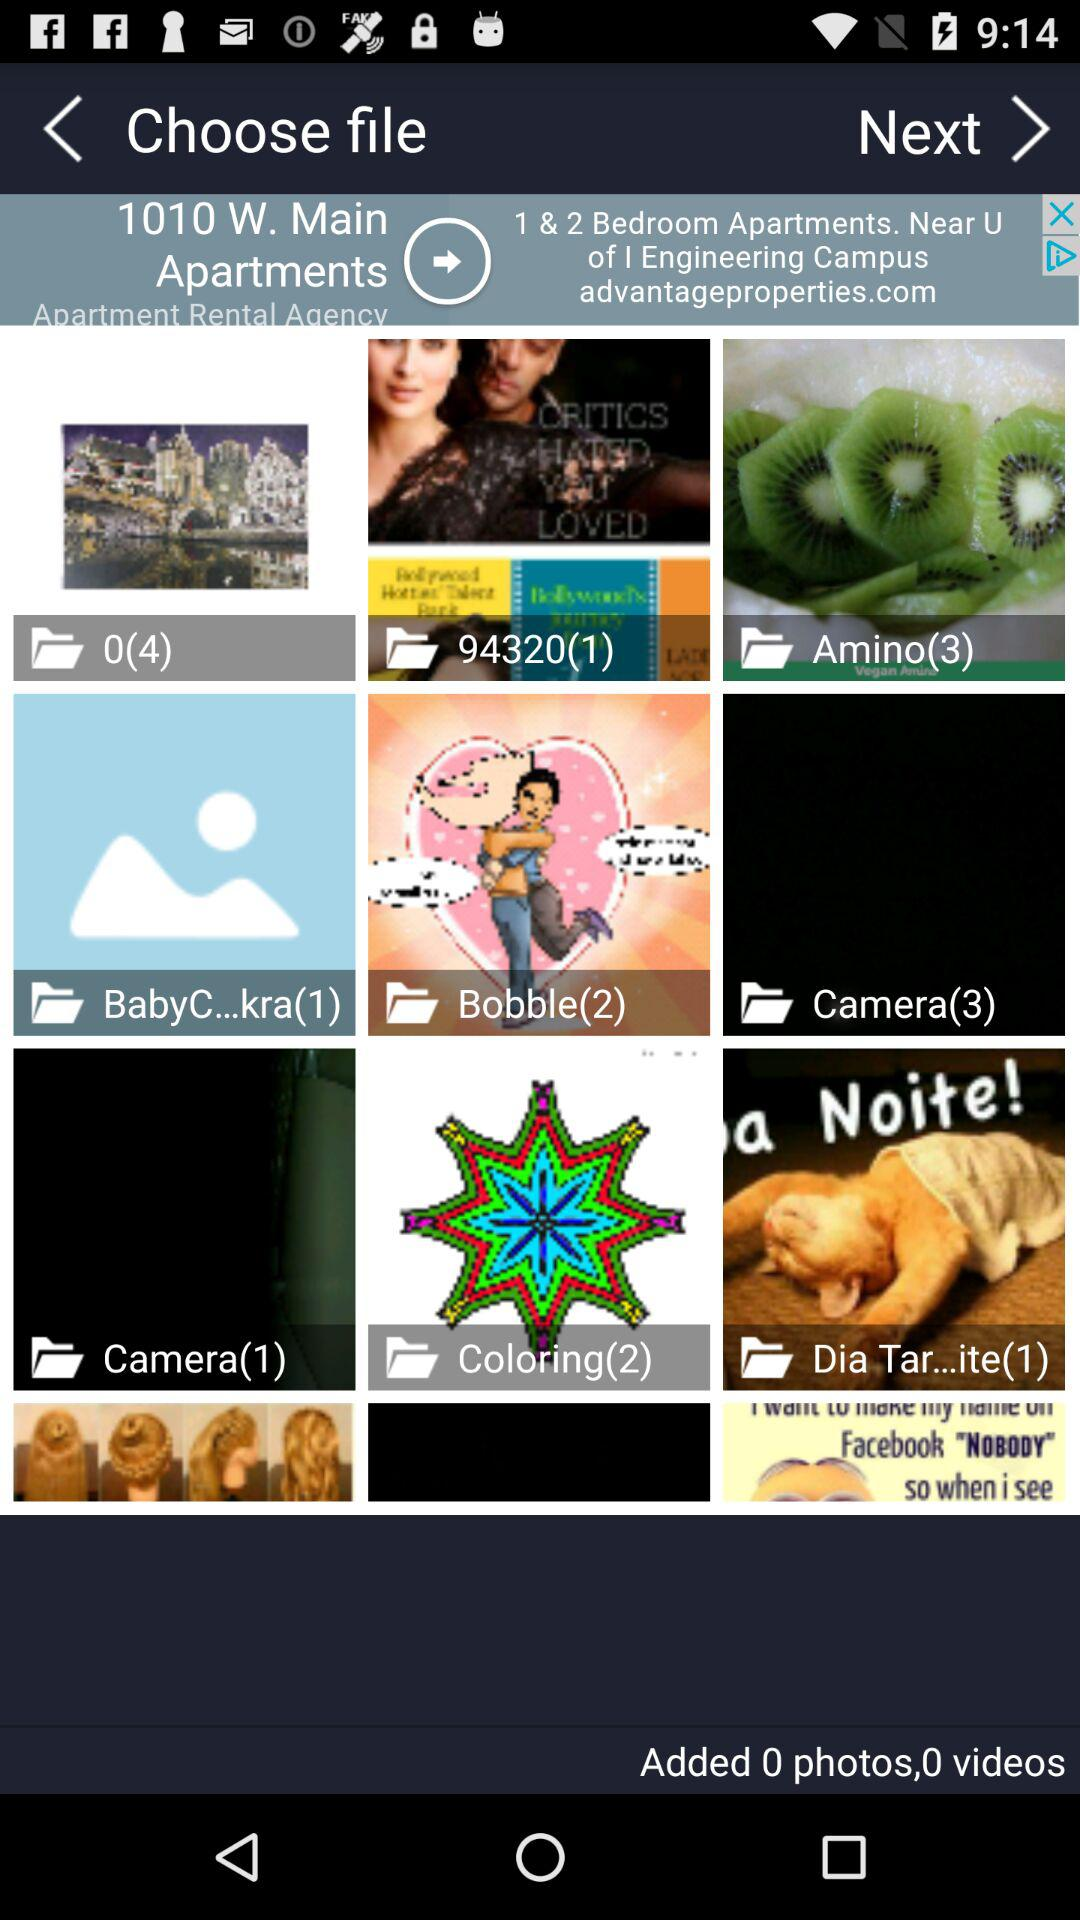What is the number of images in the "Bobble" album? The number of images in the "Bobble" album is 2. 